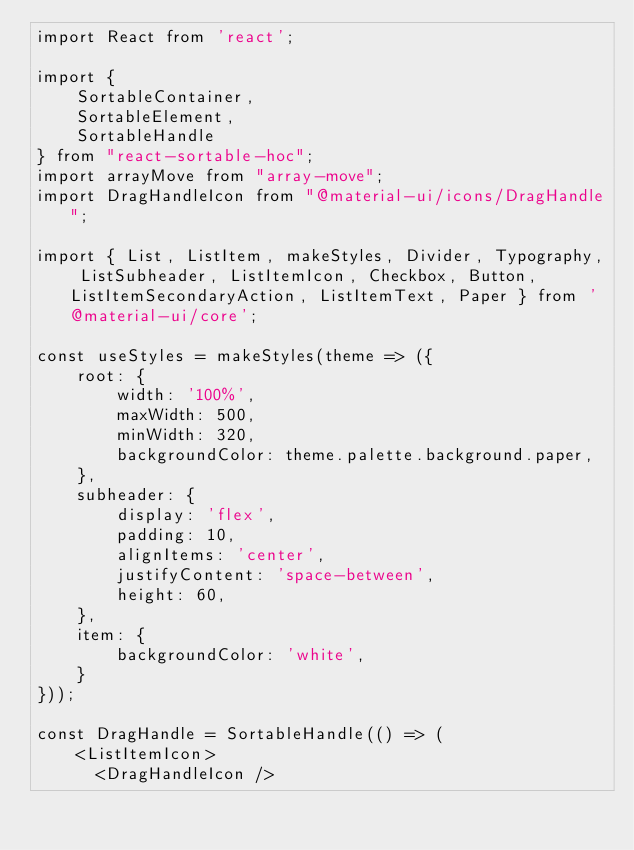Convert code to text. <code><loc_0><loc_0><loc_500><loc_500><_JavaScript_>import React from 'react';

import {
    SortableContainer,
    SortableElement,
    SortableHandle
} from "react-sortable-hoc";
import arrayMove from "array-move";
import DragHandleIcon from "@material-ui/icons/DragHandle";

import { List, ListItem, makeStyles, Divider, Typography, ListSubheader, ListItemIcon, Checkbox, Button, ListItemSecondaryAction, ListItemText, Paper } from '@material-ui/core';

const useStyles = makeStyles(theme => ({
    root: {
        width: '100%',
        maxWidth: 500,
        minWidth: 320,
        backgroundColor: theme.palette.background.paper,
    },
    subheader: {
        display: 'flex',
        padding: 10,
        alignItems: 'center',
        justifyContent: 'space-between',
        height: 60,
    },
    item: {
        backgroundColor: 'white',
    }
}));

const DragHandle = SortableHandle(() => (
    <ListItemIcon>
      <DragHandleIcon /></code> 